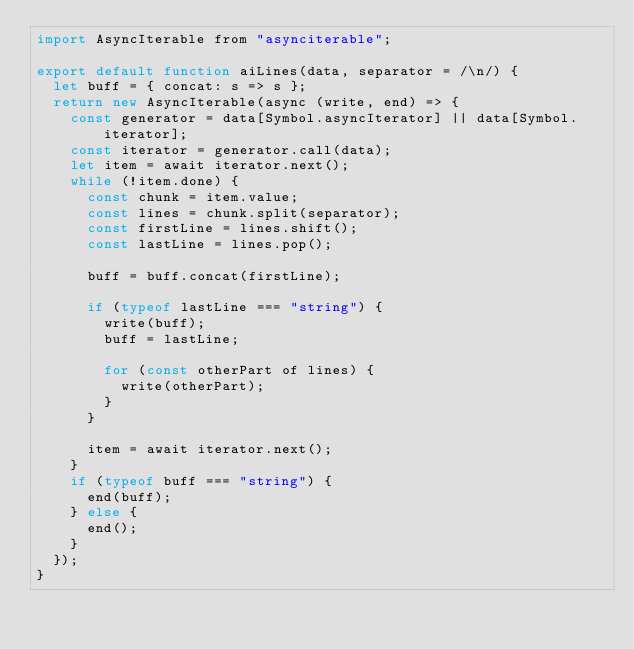Convert code to text. <code><loc_0><loc_0><loc_500><loc_500><_JavaScript_>import AsyncIterable from "asynciterable";

export default function aiLines(data, separator = /\n/) {
  let buff = { concat: s => s };
  return new AsyncIterable(async (write, end) => {
    const generator = data[Symbol.asyncIterator] || data[Symbol.iterator];
    const iterator = generator.call(data);
    let item = await iterator.next();
    while (!item.done) {
      const chunk = item.value;
      const lines = chunk.split(separator);
      const firstLine = lines.shift();
      const lastLine = lines.pop();

      buff = buff.concat(firstLine);

      if (typeof lastLine === "string") {
        write(buff);
        buff = lastLine;

        for (const otherPart of lines) {
          write(otherPart);
        }
      }

      item = await iterator.next();
    }
    if (typeof buff === "string") {
      end(buff);
    } else {
      end();
    }
  });
}
</code> 